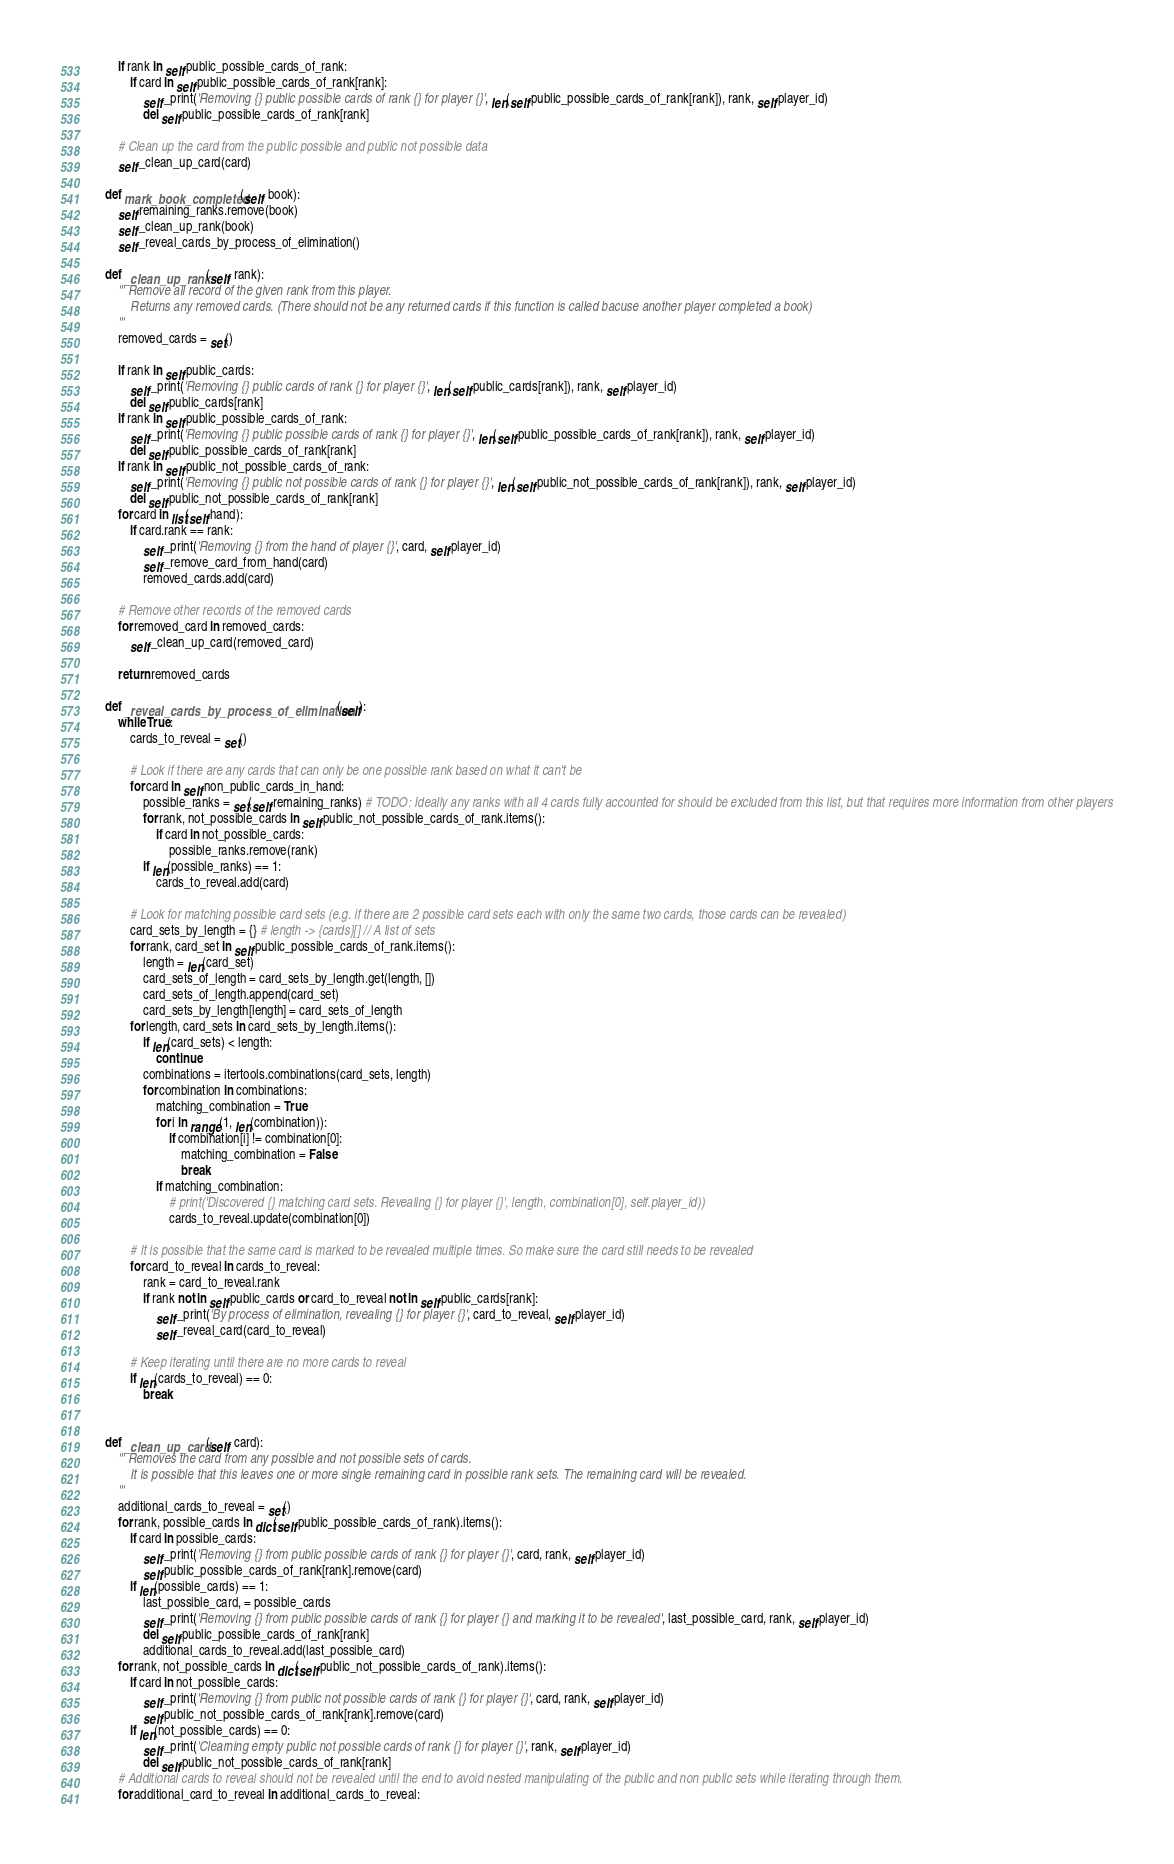Convert code to text. <code><loc_0><loc_0><loc_500><loc_500><_Python_>        if rank in self.public_possible_cards_of_rank:
            if card in self.public_possible_cards_of_rank[rank]:
                self._print('Removing {} public possible cards of rank {} for player {}', len(self.public_possible_cards_of_rank[rank]), rank, self.player_id)
                del self.public_possible_cards_of_rank[rank]

        # Clean up the card from the public possible and public not possible data
        self._clean_up_card(card)

    def mark_book_completed(self, book):
        self.remaining_ranks.remove(book)
        self._clean_up_rank(book)
        self._reveal_cards_by_process_of_elimination()

    def _clean_up_rank(self, rank):
        ''' Remove all record of the given rank from this player.
            Returns any removed cards. (There should not be any returned cards if this function is called bacuse another player completed a book)
        '''
        removed_cards = set()

        if rank in self.public_cards:
            self._print('Removing {} public cards of rank {} for player {}', len(self.public_cards[rank]), rank, self.player_id)
            del self.public_cards[rank]
        if rank in self.public_possible_cards_of_rank:
            self._print('Removing {} public possible cards of rank {} for player {}', len(self.public_possible_cards_of_rank[rank]), rank, self.player_id)
            del self.public_possible_cards_of_rank[rank]
        if rank in self.public_not_possible_cards_of_rank:
            self._print('Removing {} public not possible cards of rank {} for player {}', len(self.public_not_possible_cards_of_rank[rank]), rank, self.player_id)
            del self.public_not_possible_cards_of_rank[rank]
        for card in list(self.hand):
            if card.rank == rank:
                self._print('Removing {} from the hand of player {}', card, self.player_id)
                self._remove_card_from_hand(card)
                removed_cards.add(card)

        # Remove other records of the removed cards
        for removed_card in removed_cards:
            self._clean_up_card(removed_card)

        return removed_cards

    def _reveal_cards_by_process_of_elimination(self):
        while True:
            cards_to_reveal = set()

            # Look if there are any cards that can only be one possible rank based on what it can't be
            for card in self.non_public_cards_in_hand:
                possible_ranks = set(self.remaining_ranks) # TODO: Ideally any ranks with all 4 cards fully accounted for should be excluded from this list, but that requires more information from other players
                for rank, not_possible_cards in self.public_not_possible_cards_of_rank.items():
                    if card in not_possible_cards:
                        possible_ranks.remove(rank)
                if len(possible_ranks) == 1:
                    cards_to_reveal.add(card)

            # Look for matching possible card sets (e.g. if there are 2 possible card sets each with only the same two cards, those cards can be revealed)
            card_sets_by_length = {} # length -> {cards}[] // A list of sets
            for rank, card_set in self.public_possible_cards_of_rank.items():
                length = len(card_set)
                card_sets_of_length = card_sets_by_length.get(length, [])
                card_sets_of_length.append(card_set)
                card_sets_by_length[length] = card_sets_of_length
            for length, card_sets in card_sets_by_length.items():
                if len(card_sets) < length:
                    continue
                combinations = itertools.combinations(card_sets, length)
                for combination in combinations:
                    matching_combination = True
                    for i in range(1, len(combination)):
                        if combination[i] != combination[0]:
                            matching_combination = False
                            break
                    if matching_combination:
                        # print('Discovered {} matching card sets. Revealing {} for player {}', length, combination[0], self.player_id))
                        cards_to_reveal.update(combination[0])

            # It is possible that the same card is marked to be revealed multiple times. So make sure the card still needs to be revealed
            for card_to_reveal in cards_to_reveal:
                rank = card_to_reveal.rank
                if rank not in self.public_cards or card_to_reveal not in self.public_cards[rank]:
                    self._print('By process of elimination, revealing {} for player {}', card_to_reveal, self.player_id)
                    self._reveal_card(card_to_reveal)

            # Keep iterating until there are no more cards to reveal
            if len(cards_to_reveal) == 0:
                break


    def _clean_up_card(self, card):
        ''' Removes the card from any possible and not possible sets of cards.
            It is possible that this leaves one or more single remaining card in possible rank sets. The remaining card will be revealed.
        '''
        additional_cards_to_reveal = set()
        for rank, possible_cards in dict(self.public_possible_cards_of_rank).items():
            if card in possible_cards:
                self._print('Removing {} from public possible cards of rank {} for player {}', card, rank, self.player_id)
                self.public_possible_cards_of_rank[rank].remove(card)
            if len(possible_cards) == 1:
                last_possible_card, = possible_cards
                self._print('Removing {} from public possible cards of rank {} for player {} and marking it to be revealed', last_possible_card, rank, self.player_id)
                del self.public_possible_cards_of_rank[rank]
                additional_cards_to_reveal.add(last_possible_card)
        for rank, not_possible_cards in dict(self.public_not_possible_cards_of_rank).items():
            if card in not_possible_cards:
                self._print('Removing {} from public not possible cards of rank {} for player {}', card, rank, self.player_id)
                self.public_not_possible_cards_of_rank[rank].remove(card)
            if len(not_possible_cards) == 0:
                self._print('Clearning empty public not possible cards of rank {} for player {}', rank, self.player_id)
                del self.public_not_possible_cards_of_rank[rank]
        # Additional cards to reveal should not be revealed until the end to avoid nested manipulating of the public and non public sets while iterating through them.
        for additional_card_to_reveal in additional_cards_to_reveal:</code> 